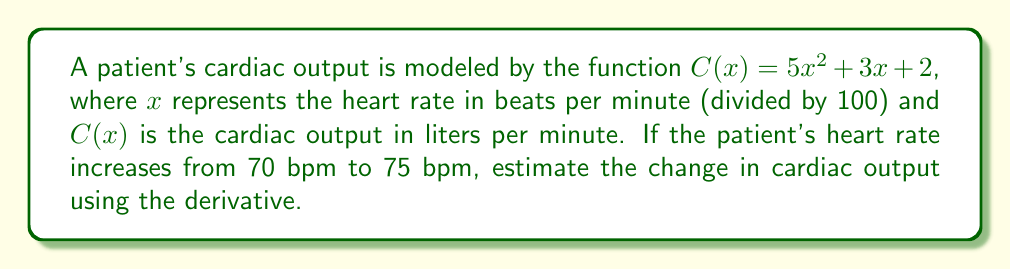Can you answer this question? To estimate the change in cardiac output, we'll use the derivative of the function $C(x)$ to approximate the rate of change.

Step 1: Find the derivative of $C(x)$.
$$C'(x) = \frac{d}{dx}(5x^2 + 3x + 2) = 10x + 3$$

Step 2: Calculate $x$ for the initial heart rate (70 bpm).
$x_1 = 70/100 = 0.7$

Step 3: Evaluate $C'(x)$ at $x = 0.7$.
$C'(0.7) = 10(0.7) + 3 = 7 + 3 = 10$

Step 4: Calculate the change in $x$.
$\Delta x = (75 - 70)/100 = 0.05$

Step 5: Estimate the change in cardiac output using the derivative.
$\Delta C \approx C'(0.7) \cdot \Delta x = 10 \cdot 0.05 = 0.5$

Therefore, the estimated change in cardiac output is approximately 0.5 liters per minute.
Answer: 0.5 L/min 